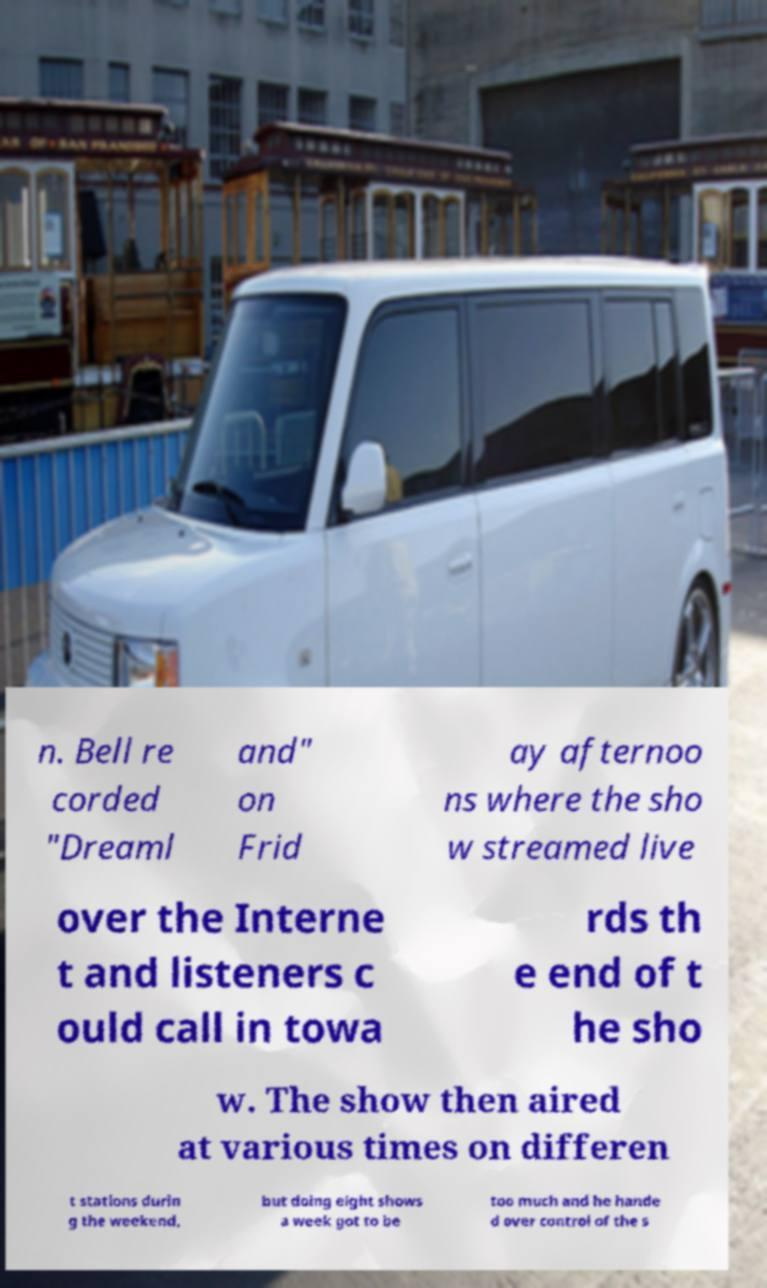Can you read and provide the text displayed in the image?This photo seems to have some interesting text. Can you extract and type it out for me? n. Bell re corded "Dreaml and" on Frid ay afternoo ns where the sho w streamed live over the Interne t and listeners c ould call in towa rds th e end of t he sho w. The show then aired at various times on differen t stations durin g the weekend, but doing eight shows a week got to be too much and he hande d over control of the s 